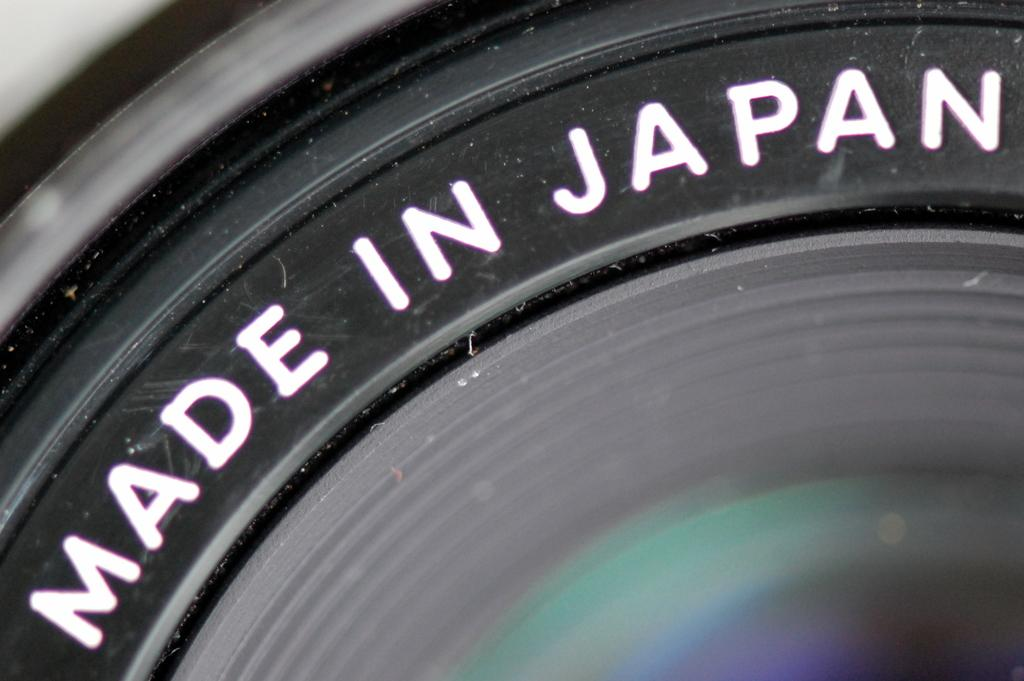What is the main subject of the picture? The main subject of the picture is a camera lens. Are there any additional details visible on the camera? Yes, there are words on the camera. What position does the person take in the image? There is no person present in the image, only a camera lens and words on the camera. What activity is the person engaged in within the image? Since there is no person in the image, there is no activity to describe. 